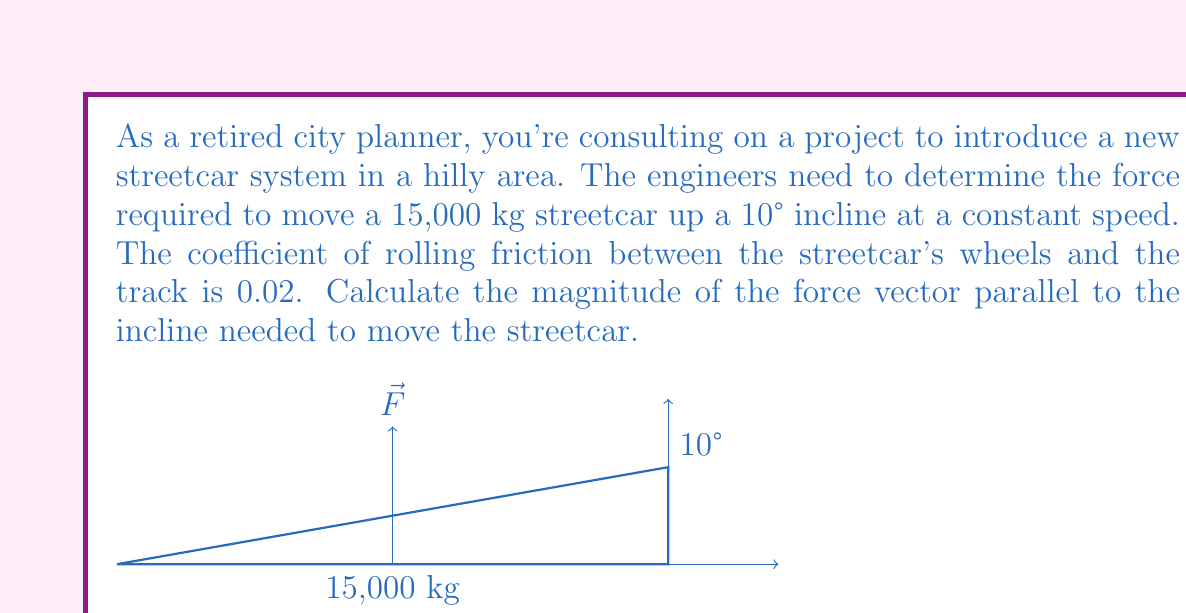Teach me how to tackle this problem. Let's approach this step-by-step:

1) First, we need to identify the forces acting on the streetcar:
   - Weight ($\vec{W}$) acting downward
   - Normal force ($\vec{N}$) perpendicular to the incline
   - Friction force ($\vec{f}$) parallel to the incline, opposing motion
   - Applied force ($\vec{F}$) parallel to the incline, in the direction of motion

2) Calculate the weight:
   $W = mg = 15,000 \text{ kg} \times 9.8 \text{ m/s}^2 = 147,000 \text{ N}$

3) Resolve the weight into components parallel and perpendicular to the incline:
   $W_{\parallel} = W \sin(10°) = 147,000 \times 0.1736 = 25,519.2 \text{ N}$
   $W_{\perp} = W \cos(10°) = 147,000 \times 0.9848 = 144,765.6 \text{ N}$

4) The normal force is equal to the perpendicular component of weight:
   $N = W_{\perp} = 144,765.6 \text{ N}$

5) Calculate the friction force:
   $f = \mu N = 0.02 \times 144,765.6 = 2,895.3 \text{ N}$

6) For constant speed, the net force should be zero. Therefore:
   $F - f - W_{\parallel} = 0$
   $F = f + W_{\parallel} = 2,895.3 + 25,519.2 = 28,414.5 \text{ N}$

Thus, the magnitude of the force vector required is 28,414.5 N.
Answer: $28,414.5 \text{ N}$ 